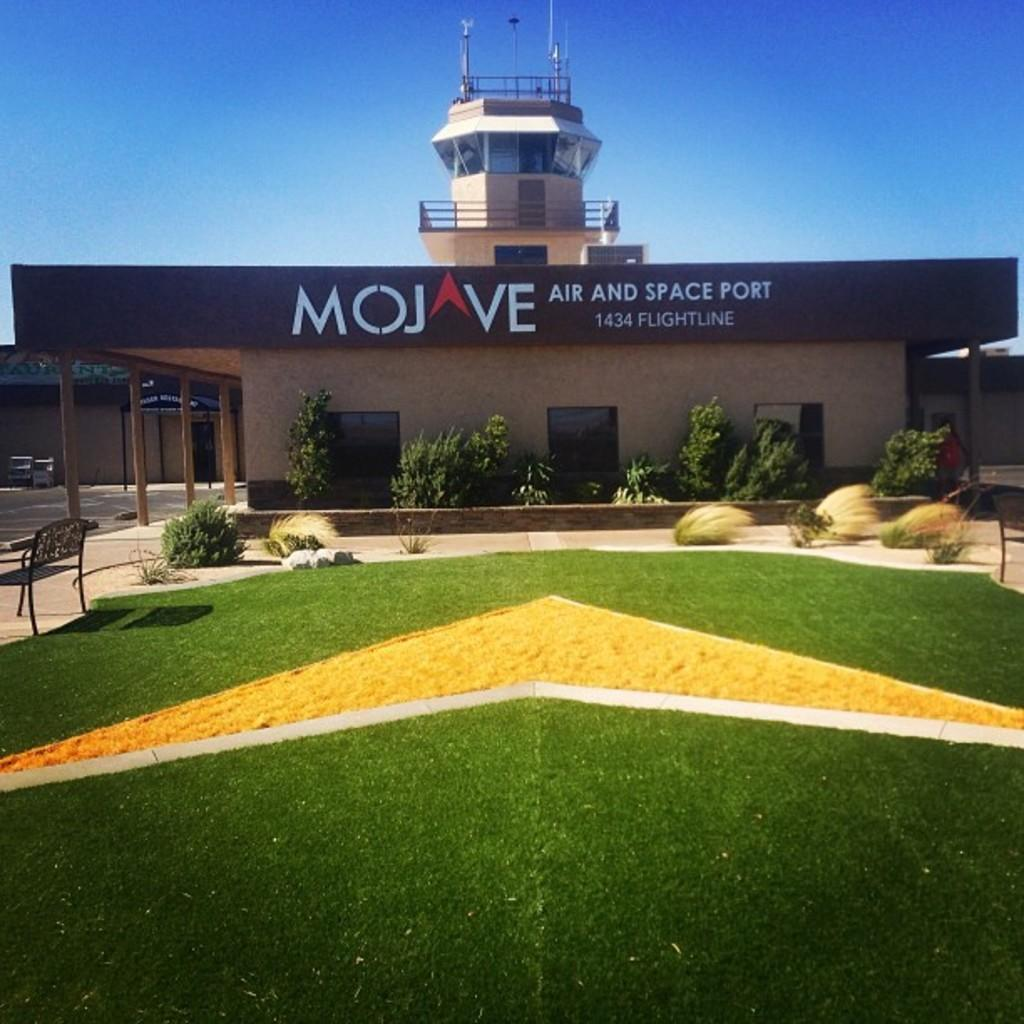What type of vegetation can be seen in the image? There is grass and plants in the image. What type of seating is present in the image? There is a chair in the image. What type of structures are visible in the image? There are houses and a building in the image. What type of signage is present in the image? There is a board in the image. What type of text can be seen in the image? There is text on a wall in the image. What is visible in the background of the image? The sky is visible in the background of the image. What type of fruit can be smelled in the image? There is no fruit present in the image, so it is not possible to determine the scent. What type of grass is growing on the roof of the building in the image? There is no grass growing on the roof of the building in the image. 